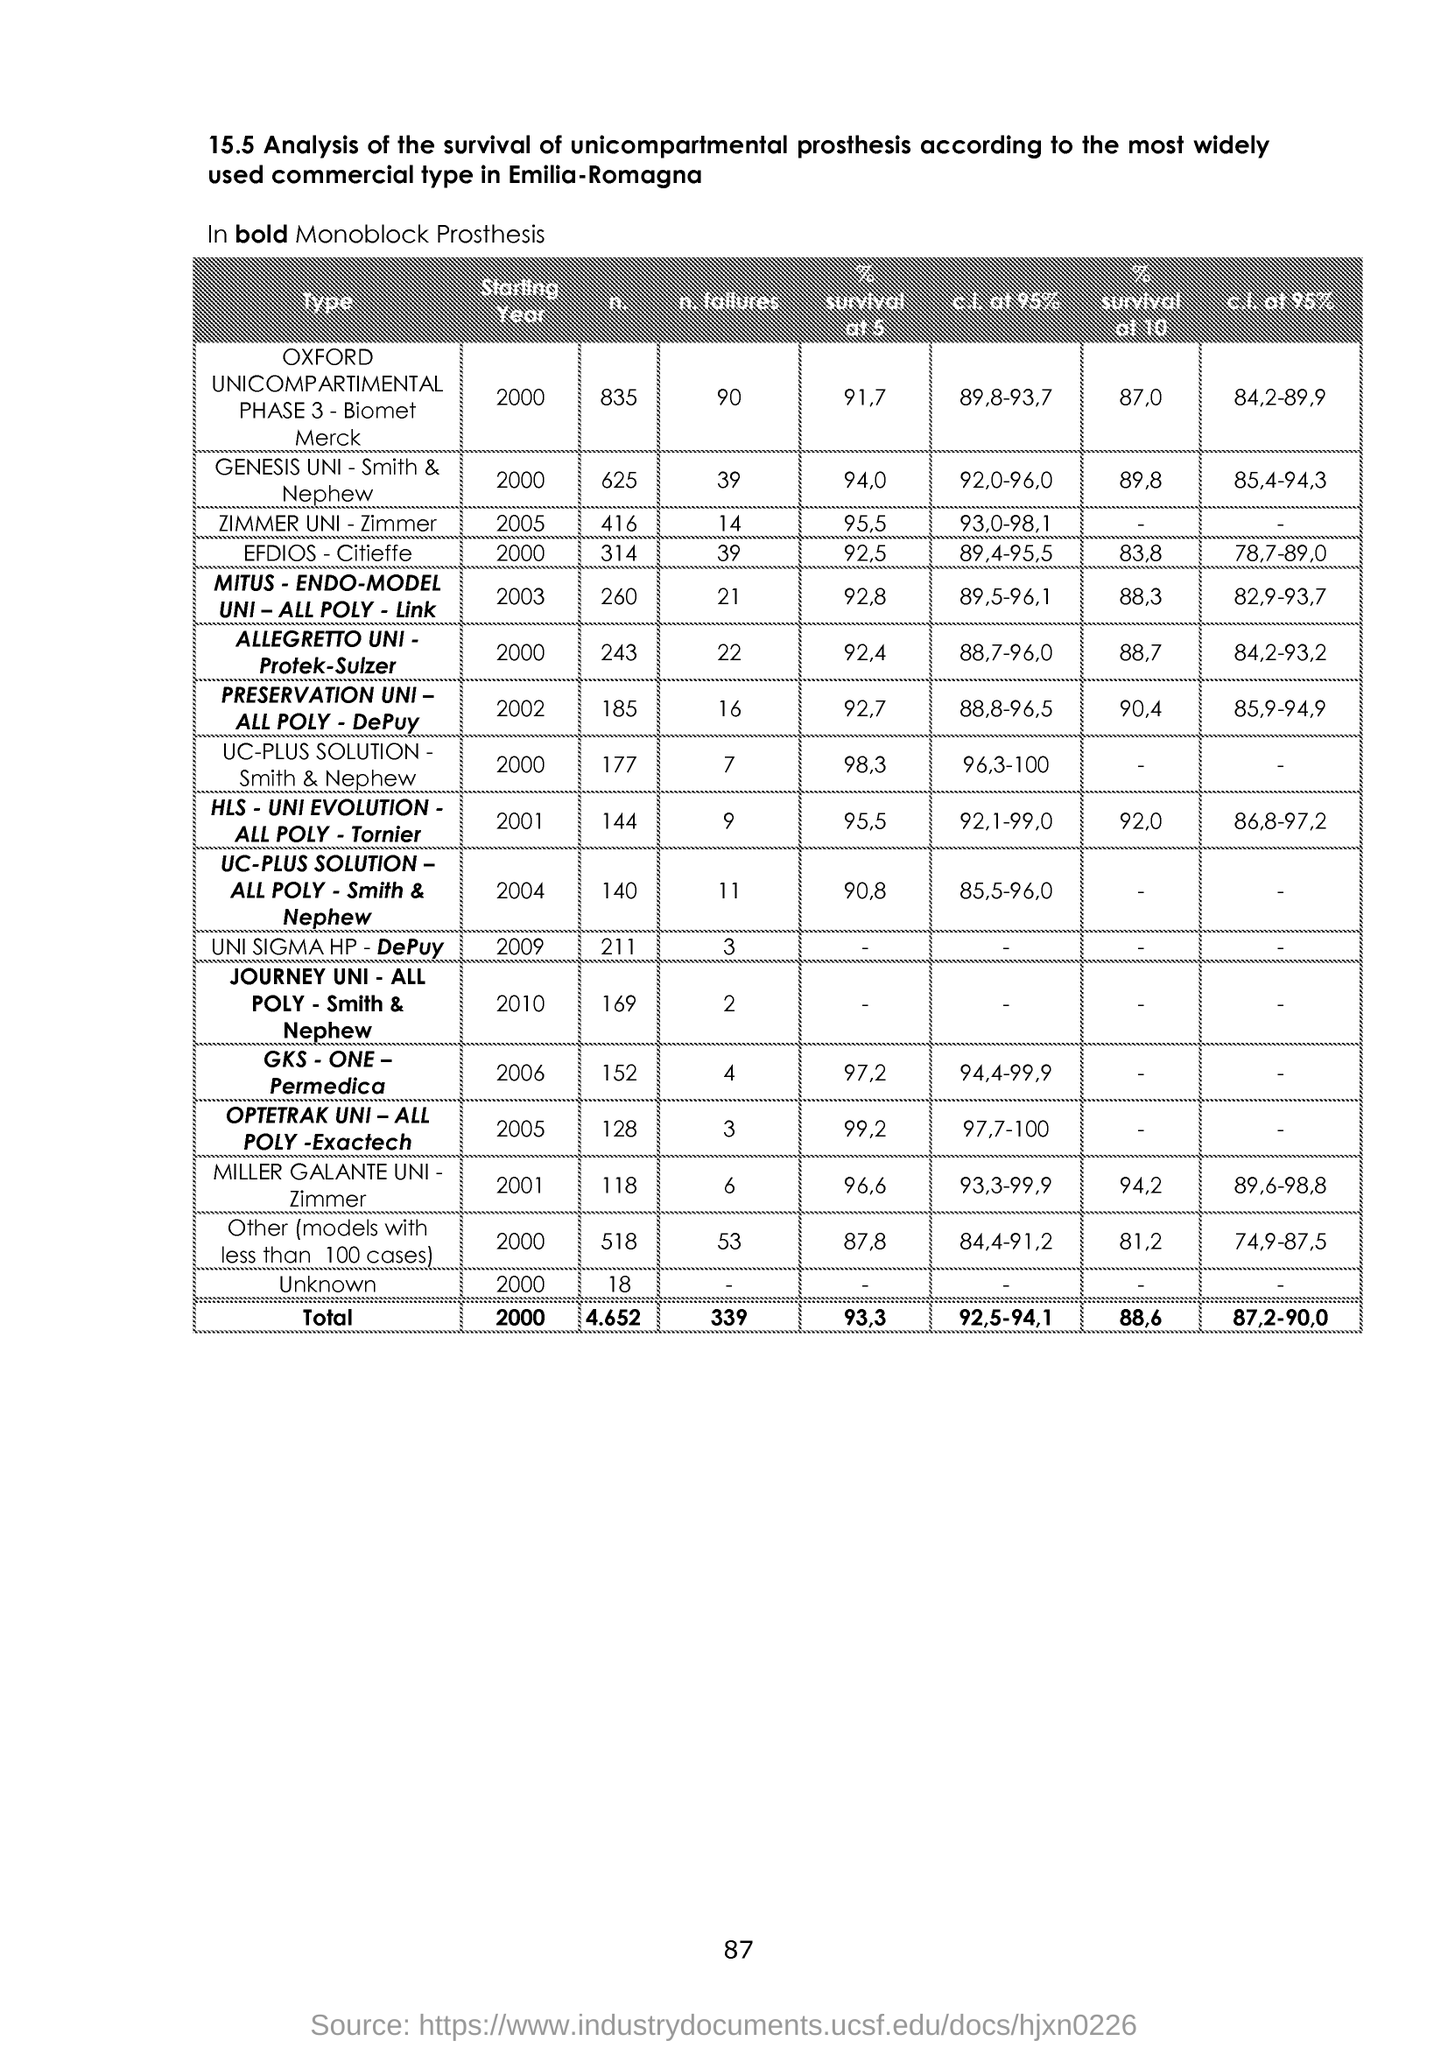Point out several critical features in this image. The page number is 87. 